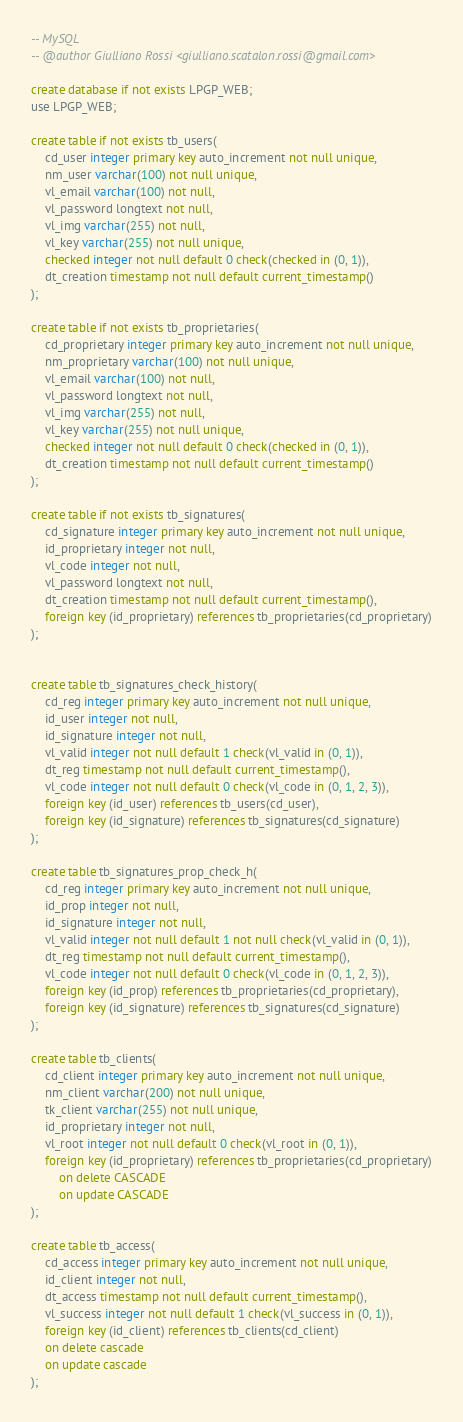<code> <loc_0><loc_0><loc_500><loc_500><_SQL_>-- MySQL
-- @author Giulliano Rossi <giulliano.scatalon.rossi@gmail.com>

create database if not exists LPGP_WEB;
use LPGP_WEB;

create table if not exists tb_users(
    cd_user integer primary key auto_increment not null unique,
    nm_user varchar(100) not null unique,
    vl_email varchar(100) not null,
    vl_password longtext not null,
    vl_img varchar(255) not null,
    vl_key varchar(255) not null unique,
    checked integer not null default 0 check(checked in (0, 1)),
    dt_creation timestamp not null default current_timestamp()
);

create table if not exists tb_proprietaries(
    cd_proprietary integer primary key auto_increment not null unique,
    nm_proprietary varchar(100) not null unique,
    vl_email varchar(100) not null,
    vl_password longtext not null,
    vl_img varchar(255) not null,
    vl_key varchar(255) not null unique,
    checked integer not null default 0 check(checked in (0, 1)),
    dt_creation timestamp not null default current_timestamp()
);

create table if not exists tb_signatures(
    cd_signature integer primary key auto_increment not null unique,
    id_proprietary integer not null,
    vl_code integer not null,
    vl_password longtext not null,
    dt_creation timestamp not null default current_timestamp(),
    foreign key (id_proprietary) references tb_proprietaries(cd_proprietary)
);


create table tb_signatures_check_history(
    cd_reg integer primary key auto_increment not null unique,
    id_user integer not null,
    id_signature integer not null,
    vl_valid integer not null default 1 check(vl_valid in (0, 1)),
    dt_reg timestamp not null default current_timestamp(),
    vl_code integer not null default 0 check(vl_code in (0, 1, 2, 3)),
    foreign key (id_user) references tb_users(cd_user),
    foreign key (id_signature) references tb_signatures(cd_signature)
);

create table tb_signatures_prop_check_h(
    cd_reg integer primary key auto_increment not null unique,
    id_prop integer not null,
    id_signature integer not null,
    vl_valid integer not null default 1 not null check(vl_valid in (0, 1)),
    dt_reg timestamp not null default current_timestamp(),
    vl_code integer not null default 0 check(vl_code in (0, 1, 2, 3)),
    foreign key (id_prop) references tb_proprietaries(cd_proprietary),
    foreign key (id_signature) references tb_signatures(cd_signature)
);

create table tb_clients(
    cd_client integer primary key auto_increment not null unique,
    nm_client varchar(200) not null unique,
    tk_client varchar(255) not null unique,
    id_proprietary integer not null,
    vl_root integer not null default 0 check(vl_root in (0, 1)),
    foreign key (id_proprietary) references tb_proprietaries(cd_proprietary)
        on delete CASCADE
        on update CASCADE
);

create table tb_access(
    cd_access integer primary key auto_increment not null unique,
    id_client integer not null,
    dt_access timestamp not null default current_timestamp(),
    vl_success integer not null default 1 check(vl_success in (0, 1)),
    foreign key (id_client) references tb_clients(cd_client)
    on delete cascade
    on update cascade
);
</code> 